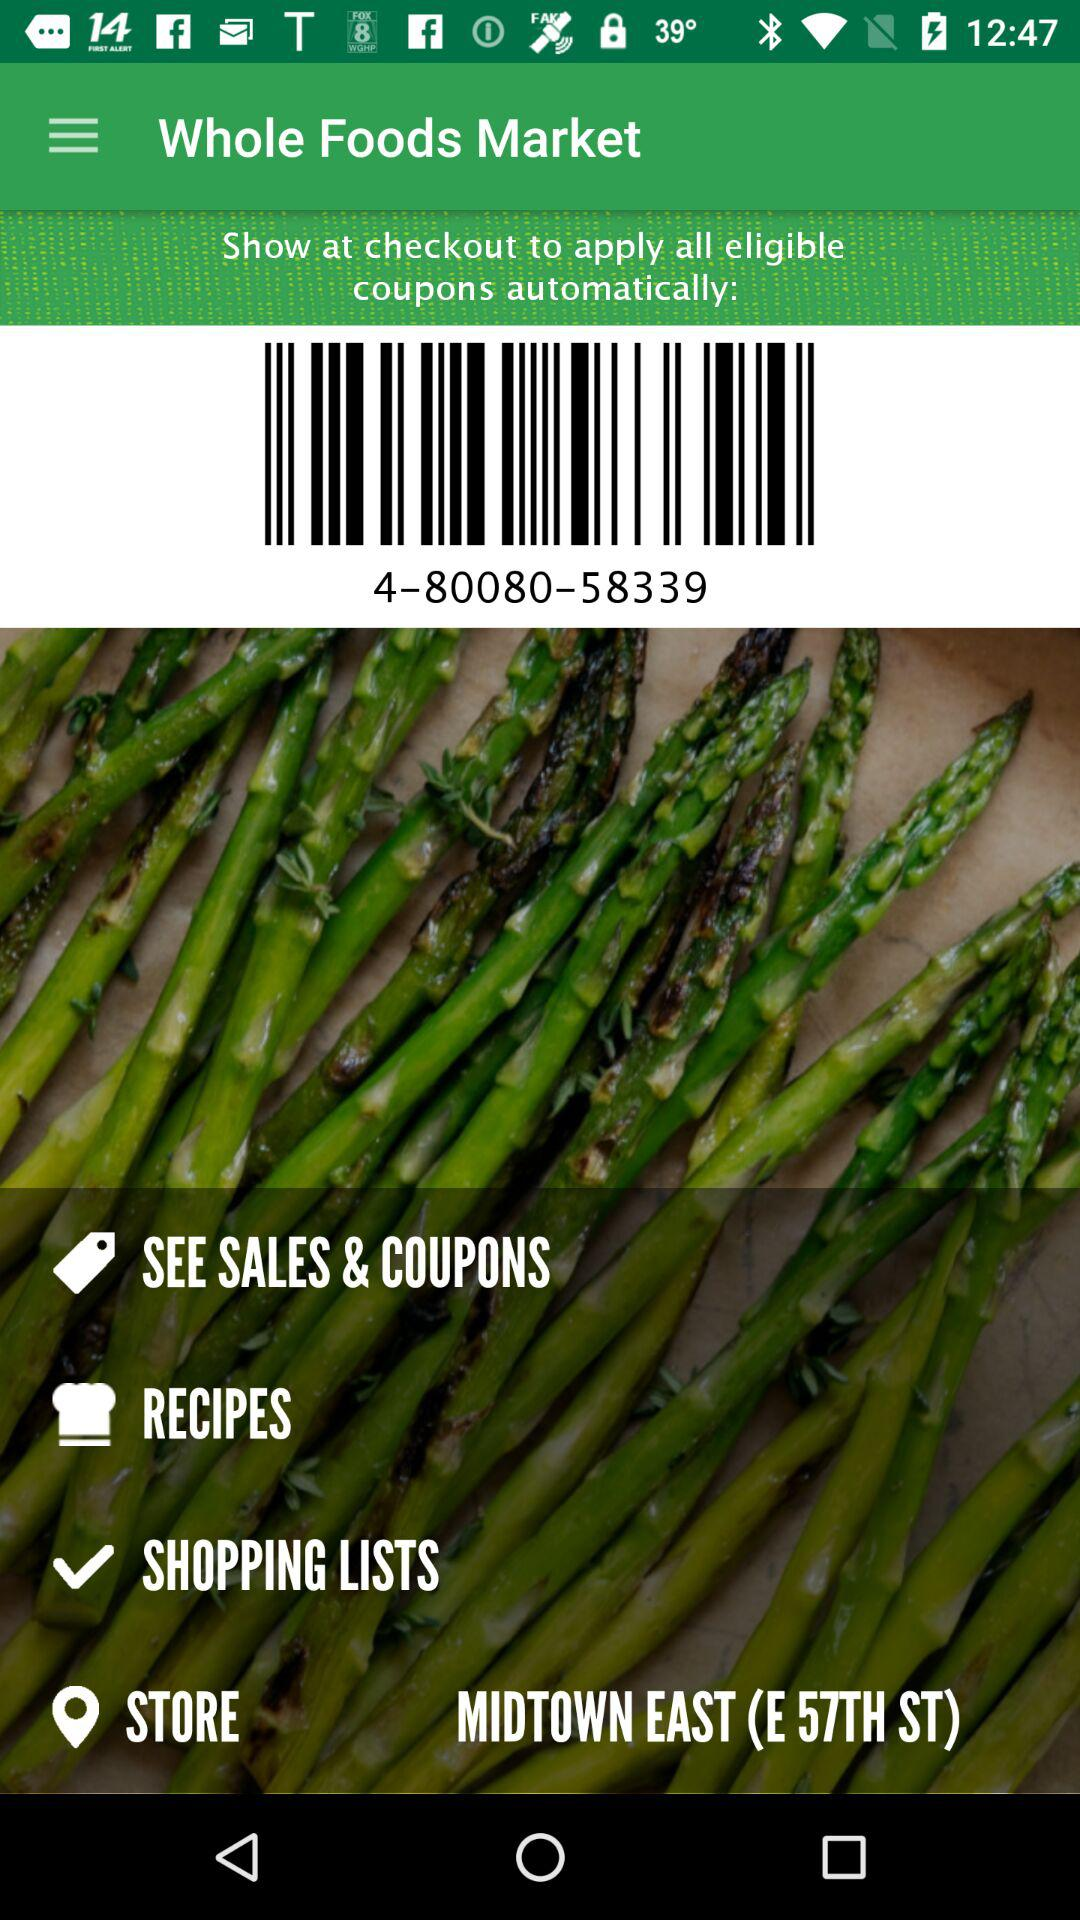How many recipes are available?
When the provided information is insufficient, respond with <no answer>. <no answer> 